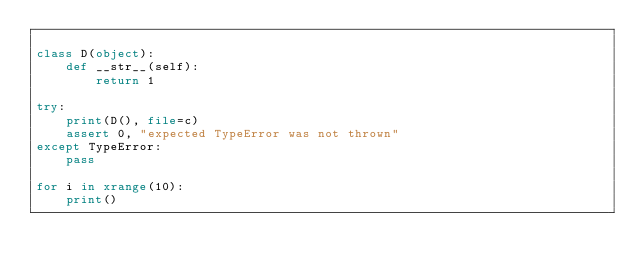Convert code to text. <code><loc_0><loc_0><loc_500><loc_500><_Python_>
class D(object):
    def __str__(self):
        return 1

try:
    print(D(), file=c)
    assert 0, "expected TypeError was not thrown"
except TypeError:
    pass

for i in xrange(10):
    print()
</code> 